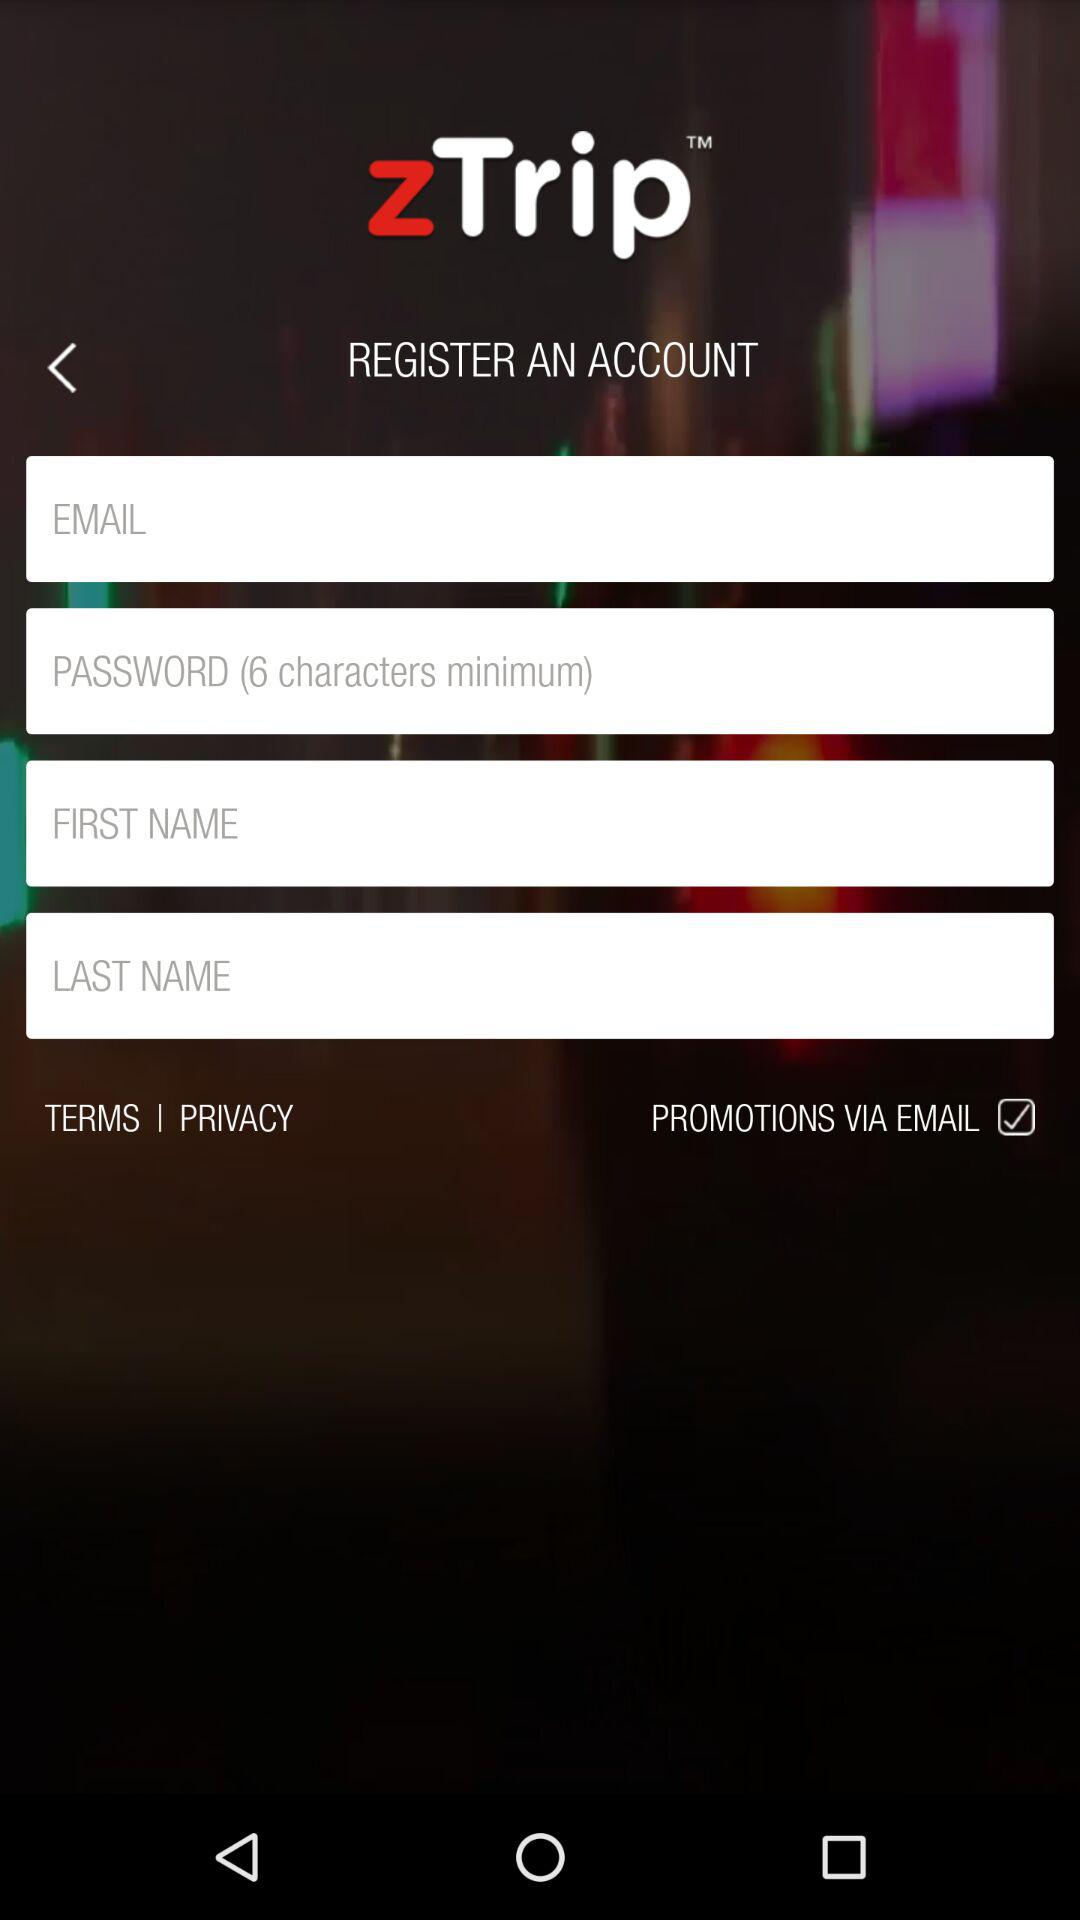How many input fields require the user to enter text?
Answer the question using a single word or phrase. 4 